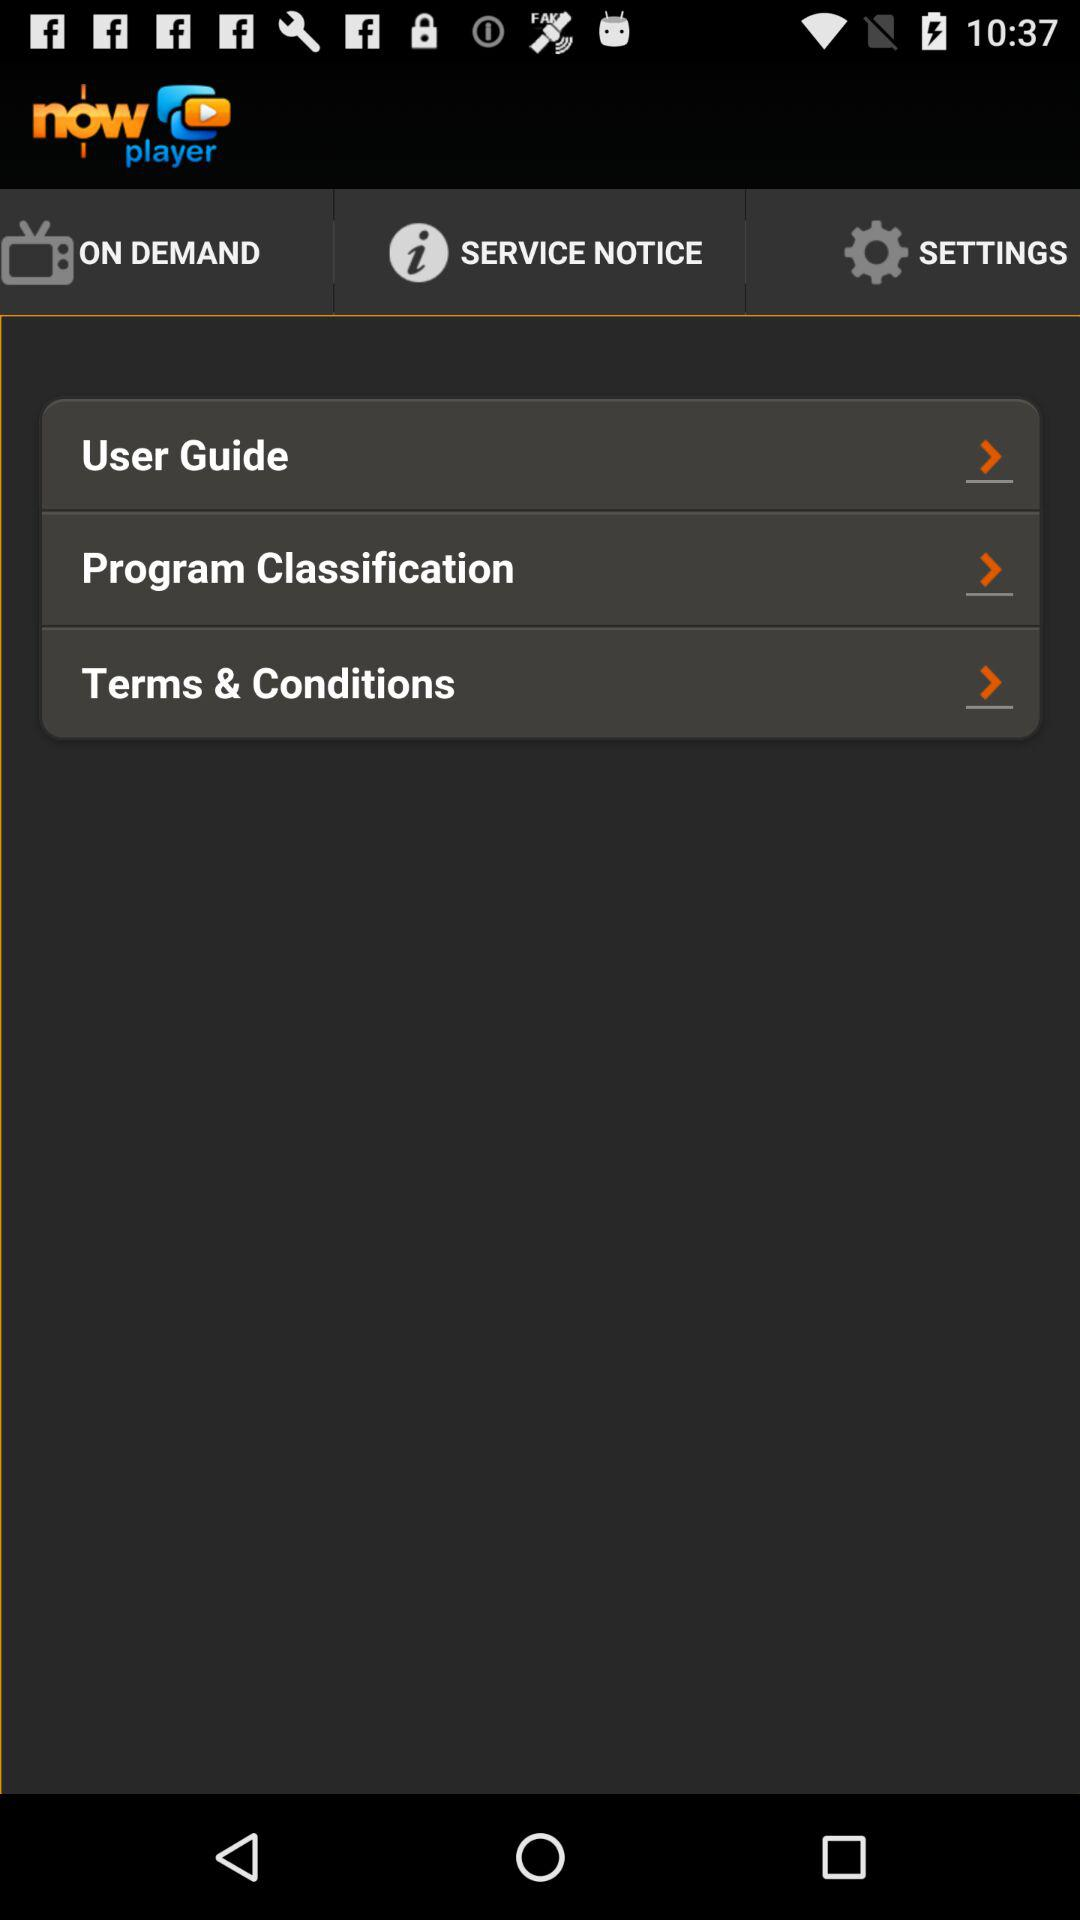What is the application name? The application name is "now player". 